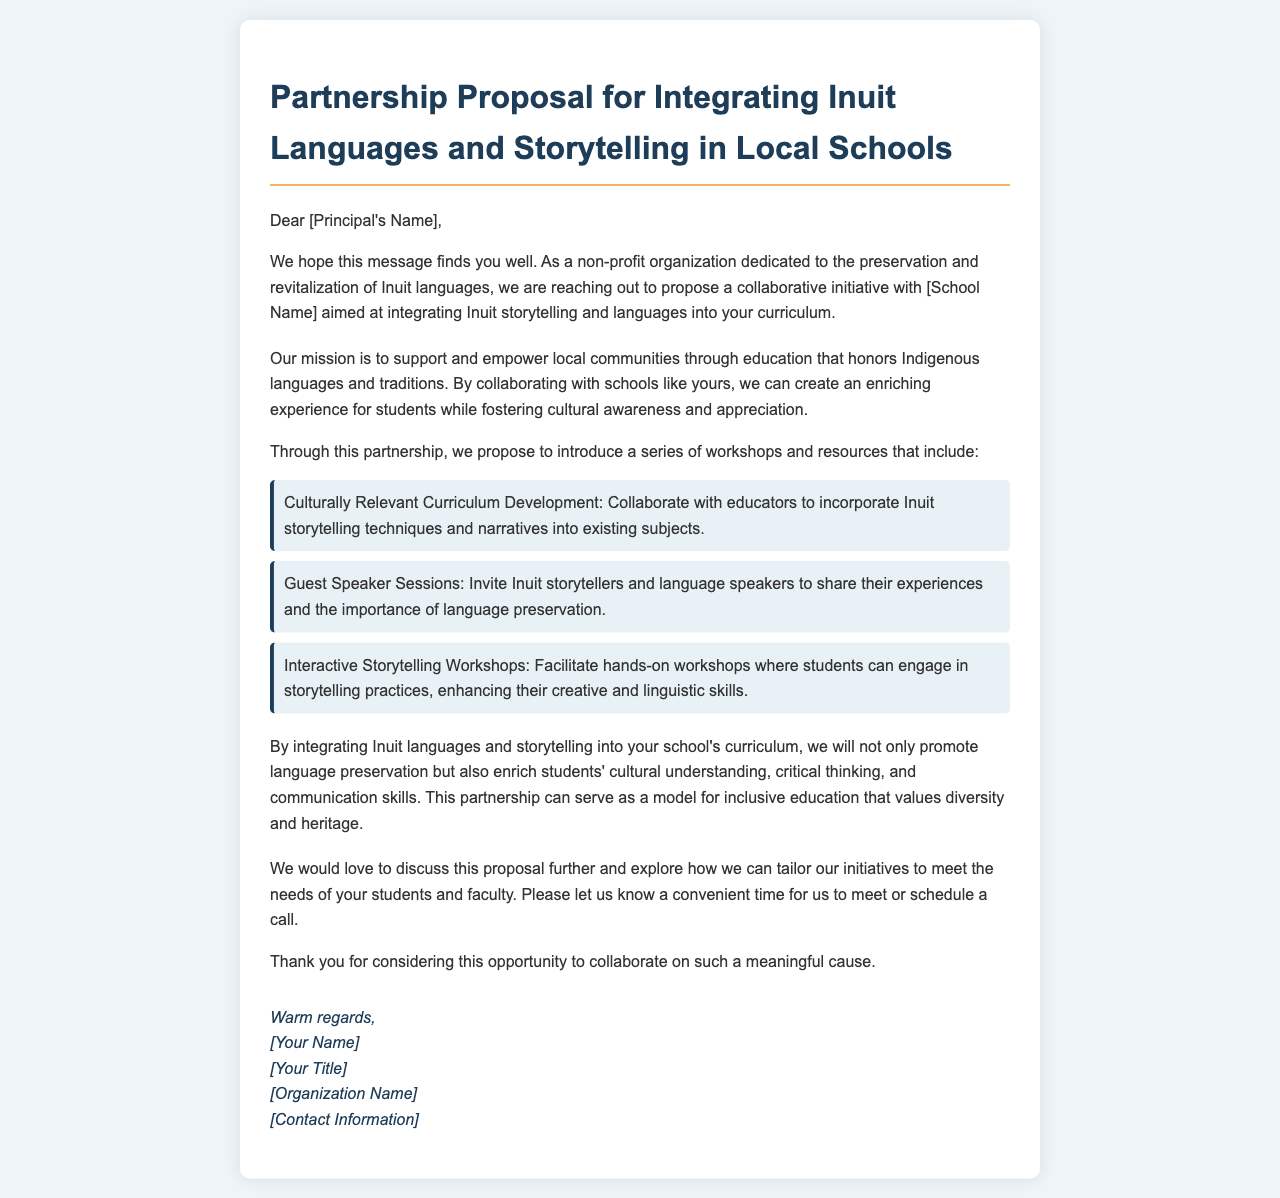What is the title of the proposal? The title is presented at the beginning of the document.
Answer: Partnership Proposal for Integrating Inuit Languages and Storytelling in Local Schools Who is the intended recipient of the email? The recipient is addressed directly in the greeting at the start of the document.
Answer: Principal What are two key elements proposed in the workshops? The document lists specific elements to be included in the partnership proposal.
Answer: Curriculum Development, Guest Speaker Sessions What cultural aspect does the organization aim to promote through this partnership? The document explains the cultural goal of the initiative in relation to the local community.
Answer: Language preservation What is the proposed method for engaging students in storytelling practices? The document mentions a specific type of workshop aimed at student involvement.
Answer: Interactive Storytelling Workshops What does the organization hope to discuss further? The closing section of the document highlights the intention to delve deeper into the initiative.
Answer: Proposal details What is the organization's primary mission as stated in the document? The mission is outlined in the proposal section.
Answer: Support and empower local communities through education How does the document sign off? The closing part of the document signifies how the communicator chooses to end the message.
Answer: Warm regards 